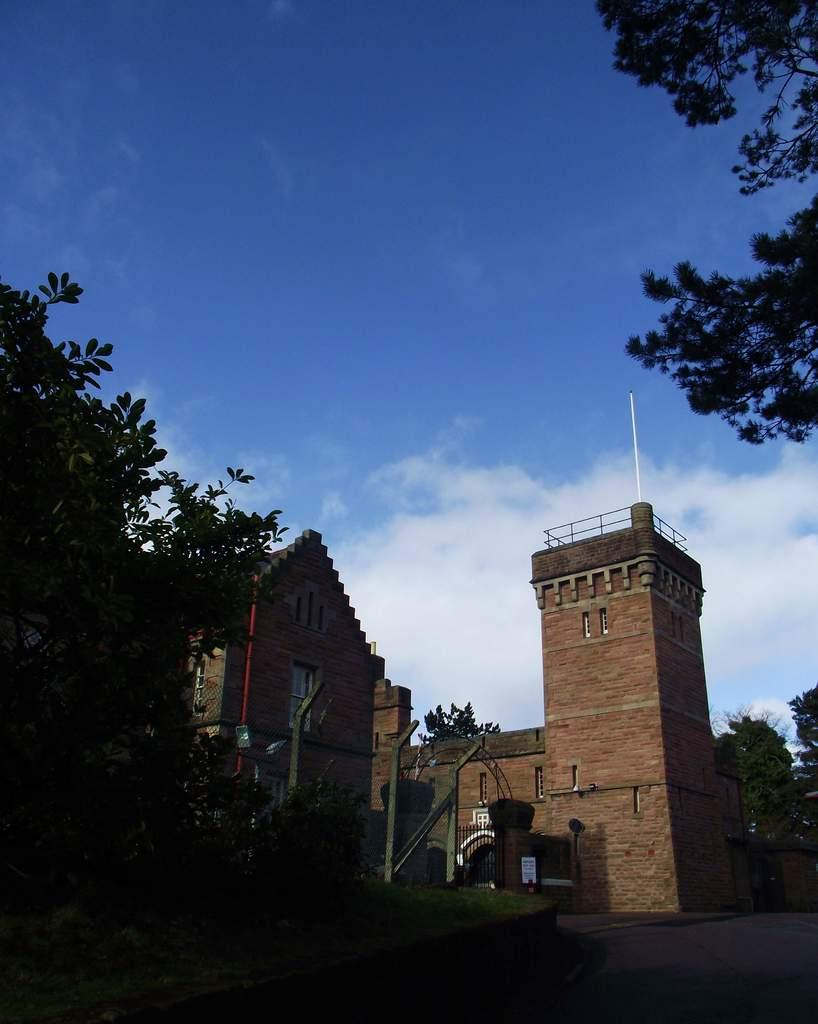What type of structures can be seen in the image? There are buildings in the image. What feature is common among the buildings? There are windows in the image. What type of barrier is present in the image? There is fencing in the image. Is there an entrance visible in the image? Yes, there is a gate in the image. What type of vegetation can be seen in the image? There are trees in the image. What object is present that might have information or instructions? There is a board in the image. What is the color of the sky in the image? The sky is blue and white in color. Can you see the nerve of the person running and smashing the board in the image? There is no person running or smashing a board in the image; it only contains buildings, windows, fencing, a gate, trees, and a board. 